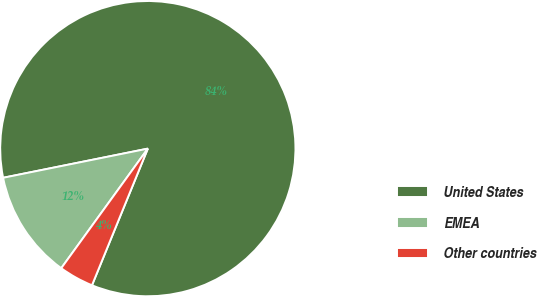Convert chart. <chart><loc_0><loc_0><loc_500><loc_500><pie_chart><fcel>United States<fcel>EMEA<fcel>Other countries<nl><fcel>84.34%<fcel>11.86%<fcel>3.8%<nl></chart> 